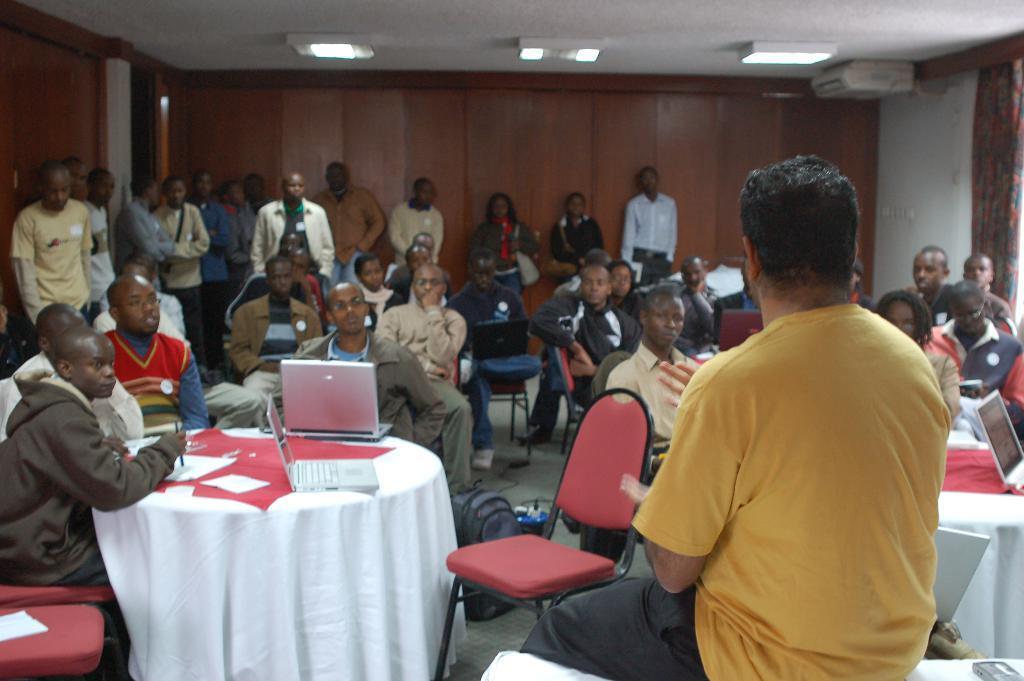In one or two sentences, can you explain what this image depicts? In this picture we can see a group of people, some people are sitting on chairs, some people are standing, here we can see tables, laptops, papers, pen, bag and some objects and in the background we can see a wall, projector, curtain, roof, lights. 